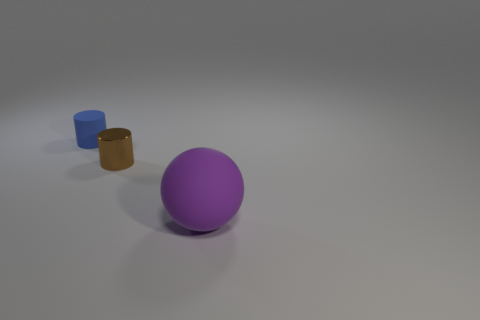What textures are present in the objects shown in the image? The objects in the image appear to have a matte texture, giving them a non-reflective finish that enhances their individual colors. 